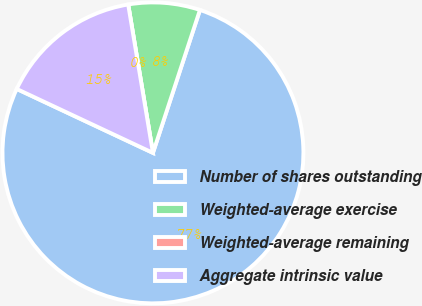Convert chart to OTSL. <chart><loc_0><loc_0><loc_500><loc_500><pie_chart><fcel>Number of shares outstanding<fcel>Weighted-average exercise<fcel>Weighted-average remaining<fcel>Aggregate intrinsic value<nl><fcel>76.92%<fcel>7.69%<fcel>0.0%<fcel>15.38%<nl></chart> 